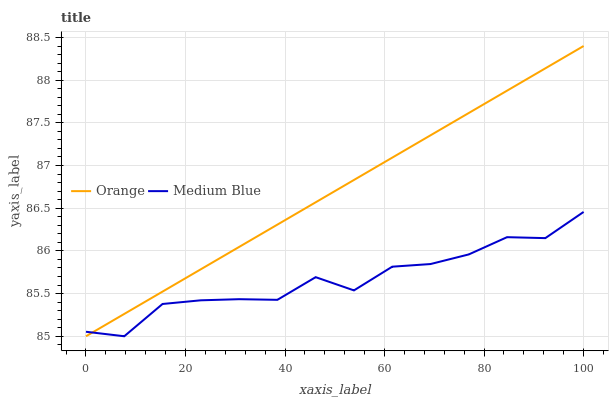Does Medium Blue have the minimum area under the curve?
Answer yes or no. Yes. Does Orange have the maximum area under the curve?
Answer yes or no. Yes. Does Medium Blue have the maximum area under the curve?
Answer yes or no. No. Is Orange the smoothest?
Answer yes or no. Yes. Is Medium Blue the roughest?
Answer yes or no. Yes. Is Medium Blue the smoothest?
Answer yes or no. No. Does Orange have the lowest value?
Answer yes or no. Yes. Does Orange have the highest value?
Answer yes or no. Yes. Does Medium Blue have the highest value?
Answer yes or no. No. Does Medium Blue intersect Orange?
Answer yes or no. Yes. Is Medium Blue less than Orange?
Answer yes or no. No. Is Medium Blue greater than Orange?
Answer yes or no. No. 